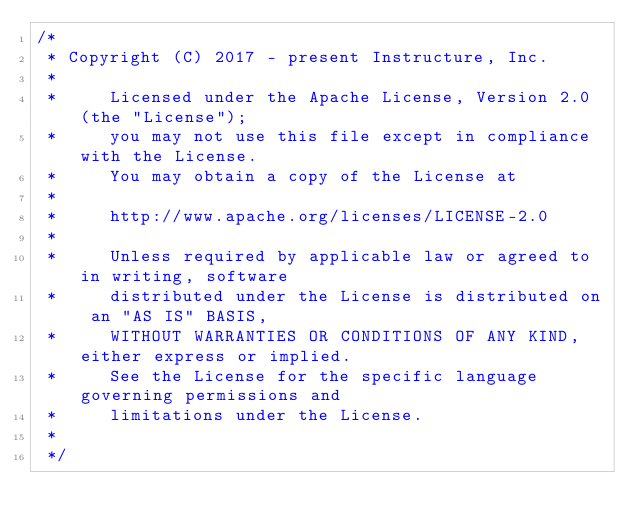<code> <loc_0><loc_0><loc_500><loc_500><_Kotlin_>/*
 * Copyright (C) 2017 - present Instructure, Inc.
 *
 *     Licensed under the Apache License, Version 2.0 (the "License");
 *     you may not use this file except in compliance with the License.
 *     You may obtain a copy of the License at
 *
 *     http://www.apache.org/licenses/LICENSE-2.0
 *
 *     Unless required by applicable law or agreed to in writing, software
 *     distributed under the License is distributed on an "AS IS" BASIS,
 *     WITHOUT WARRANTIES OR CONDITIONS OF ANY KIND, either express or implied.
 *     See the License for the specific language governing permissions and
 *     limitations under the License.
 *
 */
</code> 